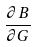<formula> <loc_0><loc_0><loc_500><loc_500>\frac { \partial B } { \partial G }</formula> 